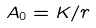<formula> <loc_0><loc_0><loc_500><loc_500>A _ { 0 } = K / r</formula> 